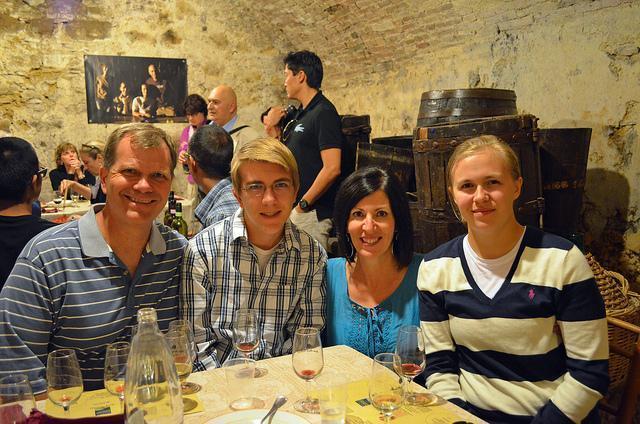How many people can be seen?
Give a very brief answer. 7. 